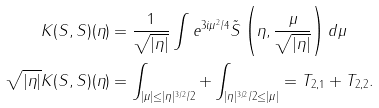Convert formula to latex. <formula><loc_0><loc_0><loc_500><loc_500>K ( S , S ) ( \eta ) & = \frac { 1 } { \sqrt { | \eta | } } \int e ^ { 3 i \mu ^ { 2 } / 4 } \tilde { S } \left ( \eta , \frac { \mu } { \sqrt { | \eta | } } \right ) d \mu \\ \sqrt { | \eta | } K ( S , S ) ( \eta ) & = \int _ { | \mu | \leq | \eta | ^ { 3 / 2 } / 2 } + \int _ { | \eta | ^ { 3 / 2 } / 2 \leq | \mu | } = T _ { 2 , 1 } + T _ { 2 , 2 } .</formula> 